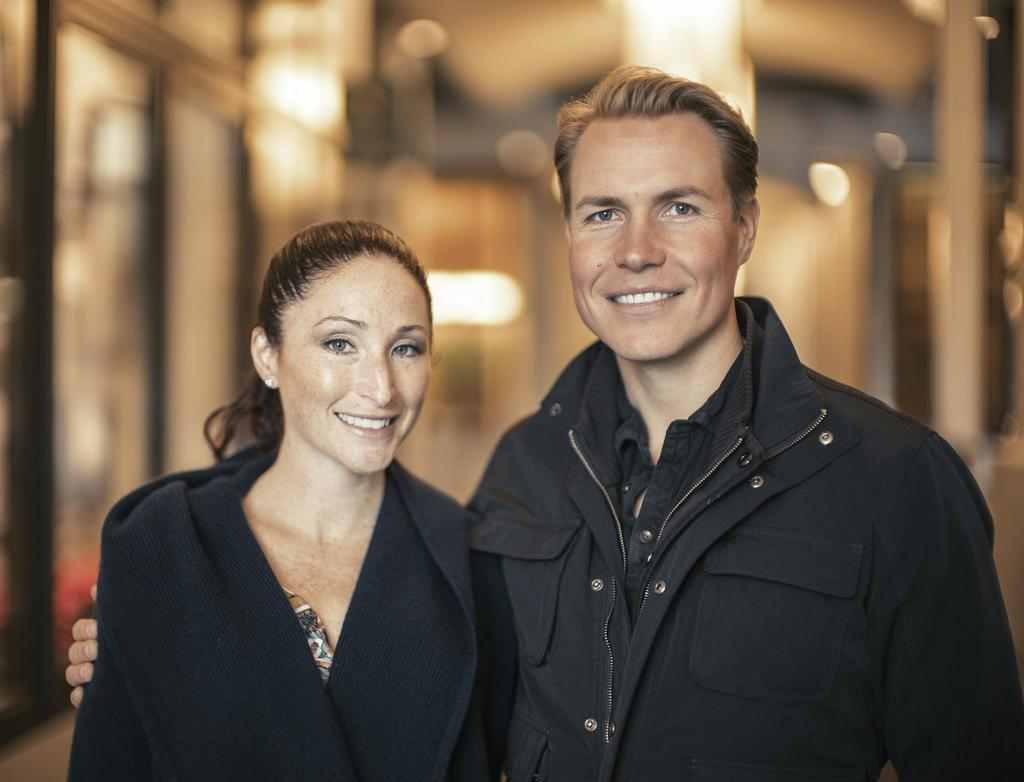How many people are in the image? There are two persons in the image. What are the persons doing in the image? The persons are standing and smiling. Can you describe the background of the image? The background of the image is blurred. What type of donkey can be seen in the image? There is no donkey present in the image. What is the air quality like in the image? The air quality cannot be determined from the image, as it only shows two persons standing and smiling with a blurred background. 